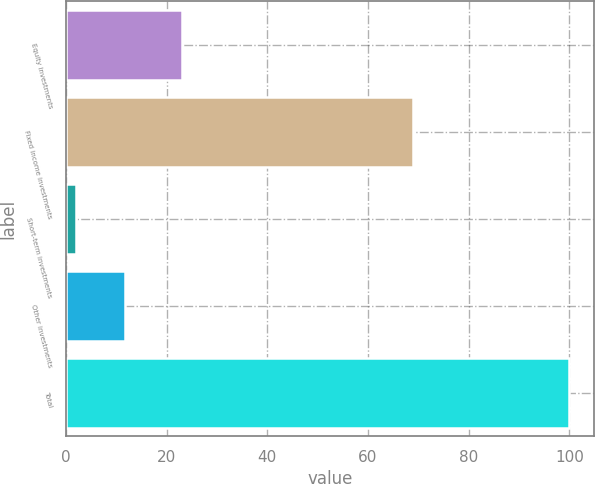Convert chart. <chart><loc_0><loc_0><loc_500><loc_500><bar_chart><fcel>Equity investments<fcel>Fixed income investments<fcel>Short-term investments<fcel>Other investments<fcel>Total<nl><fcel>23<fcel>69<fcel>2<fcel>11.8<fcel>100<nl></chart> 